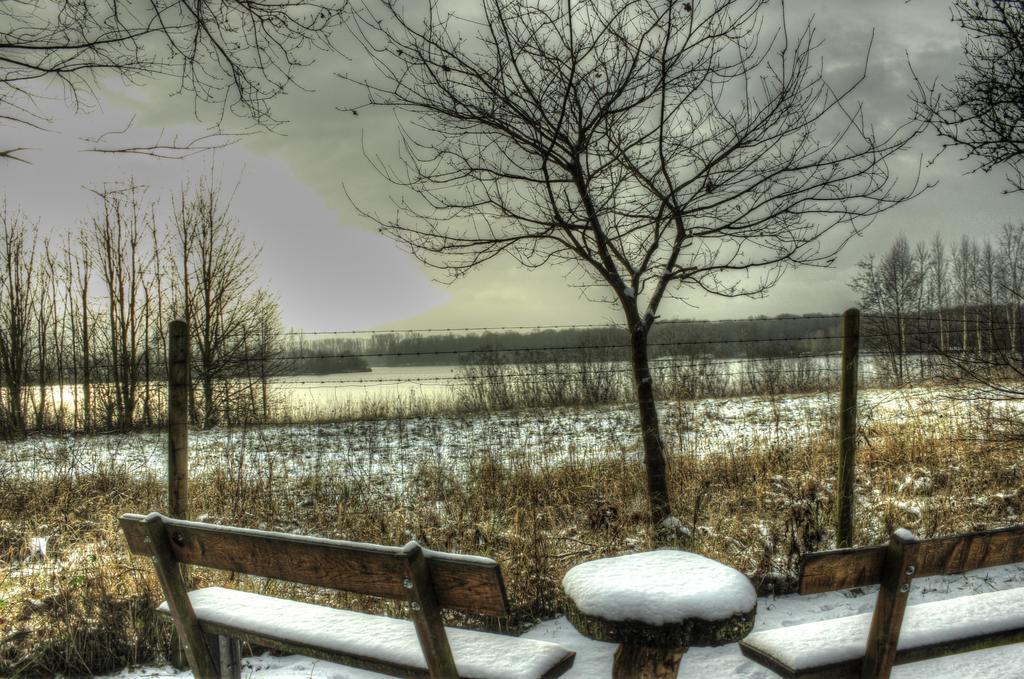Describe this image in one or two sentences. In this image, there are a few trees, plants. We can see the ground. There are a few benches and a table. We can see some snow and the fence. We can see some grass and the sky with clouds. 